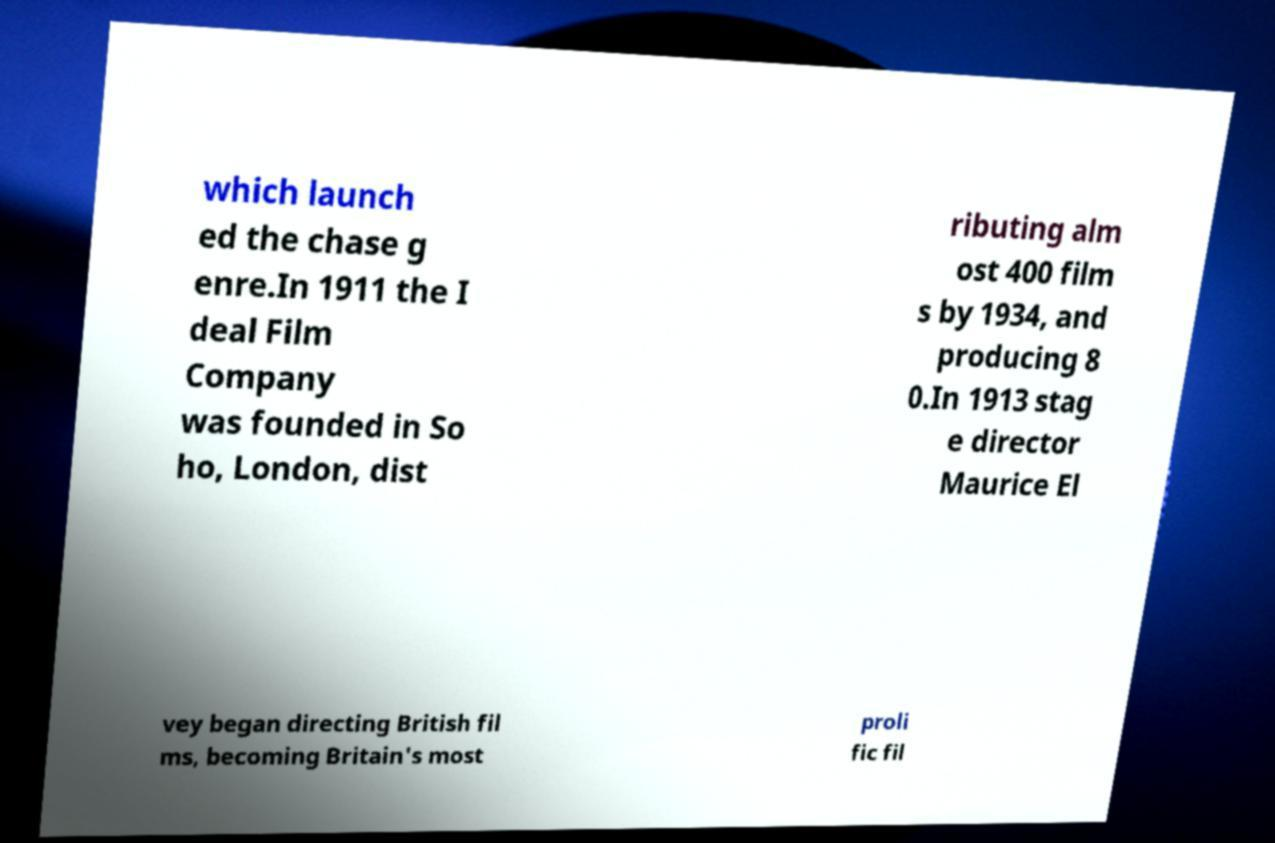Please read and relay the text visible in this image. What does it say? which launch ed the chase g enre.In 1911 the I deal Film Company was founded in So ho, London, dist ributing alm ost 400 film s by 1934, and producing 8 0.In 1913 stag e director Maurice El vey began directing British fil ms, becoming Britain's most proli fic fil 